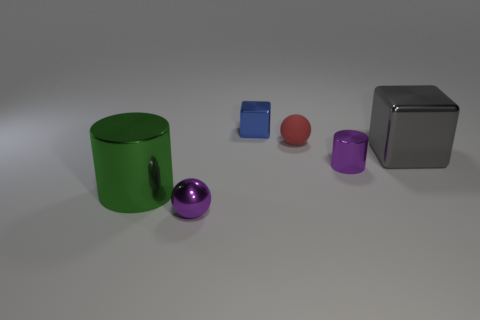Add 1 tiny blocks. How many objects exist? 7 Subtract all spheres. How many objects are left? 4 Add 5 large green metal cylinders. How many large green metal cylinders are left? 6 Add 1 big green shiny things. How many big green shiny things exist? 2 Subtract 0 brown cylinders. How many objects are left? 6 Subtract all big gray metallic things. Subtract all purple metal cylinders. How many objects are left? 4 